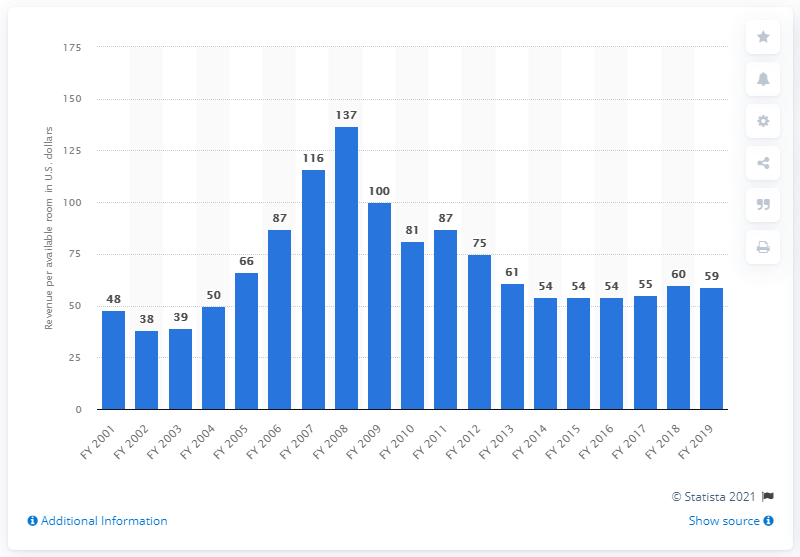Point out several critical features in this image. The revenue per available room of hotels in India during the fiscal year 2019 was approximately 59. 